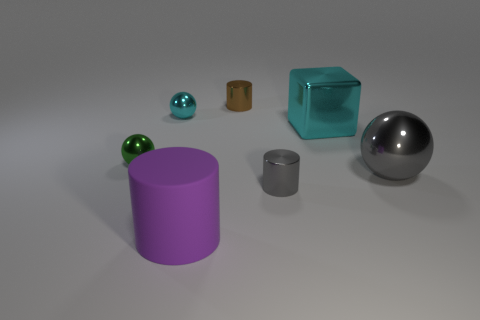Subtract all big purple cylinders. How many cylinders are left? 2 Subtract all green spheres. How many spheres are left? 2 Subtract all green spheres. How many brown cubes are left? 0 Subtract all small purple objects. Subtract all tiny green balls. How many objects are left? 6 Add 4 small cyan spheres. How many small cyan spheres are left? 5 Add 2 tiny gray things. How many tiny gray things exist? 3 Add 3 small red shiny blocks. How many objects exist? 10 Subtract 0 red cylinders. How many objects are left? 7 Subtract all blocks. How many objects are left? 6 Subtract 2 spheres. How many spheres are left? 1 